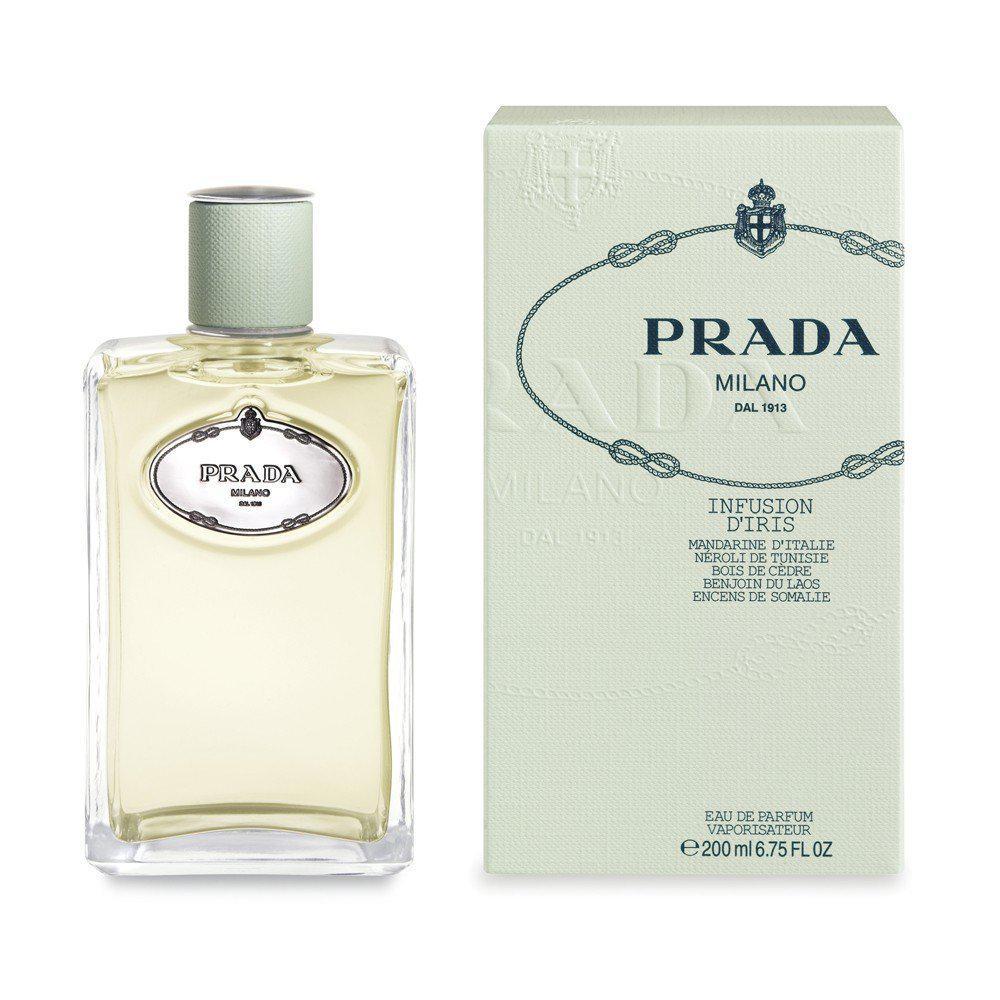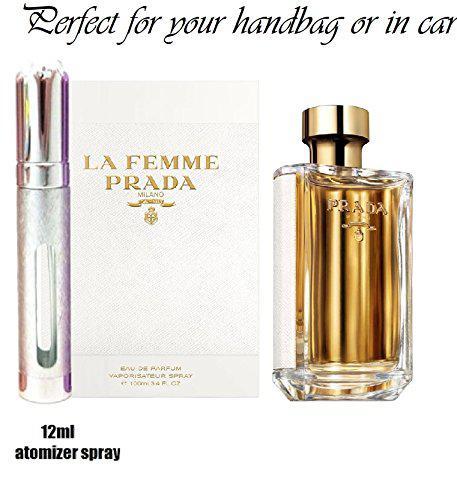The first image is the image on the left, the second image is the image on the right. Examine the images to the left and right. Is the description "One image shows Prada perfume next to its box and the other shows Prada perfume without a box." accurate? Answer yes or no. No. 